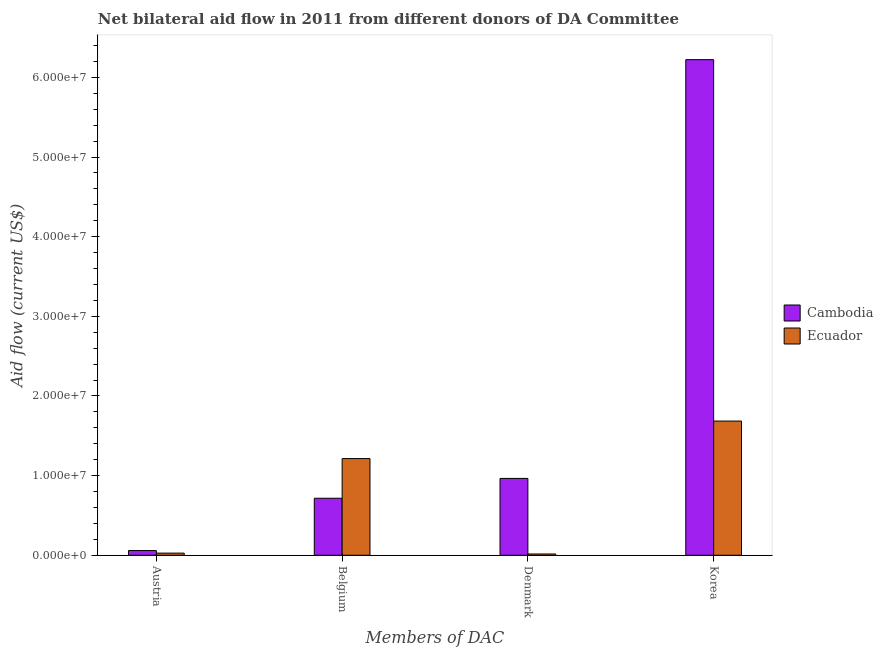How many different coloured bars are there?
Make the answer very short. 2. How many groups of bars are there?
Keep it short and to the point. 4. Are the number of bars on each tick of the X-axis equal?
Ensure brevity in your answer.  Yes. How many bars are there on the 2nd tick from the left?
Your answer should be compact. 2. What is the label of the 4th group of bars from the left?
Ensure brevity in your answer.  Korea. What is the amount of aid given by belgium in Cambodia?
Give a very brief answer. 7.16e+06. Across all countries, what is the maximum amount of aid given by belgium?
Make the answer very short. 1.21e+07. Across all countries, what is the minimum amount of aid given by denmark?
Ensure brevity in your answer.  1.60e+05. In which country was the amount of aid given by denmark maximum?
Provide a short and direct response. Cambodia. In which country was the amount of aid given by belgium minimum?
Your answer should be very brief. Cambodia. What is the total amount of aid given by korea in the graph?
Offer a very short reply. 7.91e+07. What is the difference between the amount of aid given by belgium in Cambodia and that in Ecuador?
Your answer should be compact. -4.98e+06. What is the difference between the amount of aid given by korea in Ecuador and the amount of aid given by belgium in Cambodia?
Provide a succinct answer. 9.69e+06. What is the average amount of aid given by denmark per country?
Provide a succinct answer. 4.90e+06. What is the difference between the amount of aid given by denmark and amount of aid given by korea in Cambodia?
Your answer should be compact. -5.26e+07. In how many countries, is the amount of aid given by austria greater than 38000000 US$?
Your answer should be very brief. 0. What is the ratio of the amount of aid given by austria in Cambodia to that in Ecuador?
Offer a terse response. 2.19. Is the amount of aid given by korea in Ecuador less than that in Cambodia?
Your answer should be very brief. Yes. Is the difference between the amount of aid given by belgium in Ecuador and Cambodia greater than the difference between the amount of aid given by korea in Ecuador and Cambodia?
Provide a succinct answer. Yes. What is the difference between the highest and the second highest amount of aid given by korea?
Offer a terse response. 4.54e+07. What is the difference between the highest and the lowest amount of aid given by denmark?
Offer a terse response. 9.49e+06. Is the sum of the amount of aid given by denmark in Cambodia and Ecuador greater than the maximum amount of aid given by austria across all countries?
Keep it short and to the point. Yes. Is it the case that in every country, the sum of the amount of aid given by denmark and amount of aid given by korea is greater than the sum of amount of aid given by austria and amount of aid given by belgium?
Give a very brief answer. No. What does the 2nd bar from the left in Belgium represents?
Provide a succinct answer. Ecuador. What does the 2nd bar from the right in Korea represents?
Your answer should be very brief. Cambodia. Is it the case that in every country, the sum of the amount of aid given by austria and amount of aid given by belgium is greater than the amount of aid given by denmark?
Your answer should be very brief. No. How many bars are there?
Your response must be concise. 8. How many countries are there in the graph?
Offer a terse response. 2. What is the difference between two consecutive major ticks on the Y-axis?
Give a very brief answer. 1.00e+07. Are the values on the major ticks of Y-axis written in scientific E-notation?
Keep it short and to the point. Yes. Does the graph contain any zero values?
Offer a terse response. No. Does the graph contain grids?
Offer a terse response. No. Where does the legend appear in the graph?
Your answer should be very brief. Center right. How many legend labels are there?
Offer a very short reply. 2. How are the legend labels stacked?
Your response must be concise. Vertical. What is the title of the graph?
Your response must be concise. Net bilateral aid flow in 2011 from different donors of DA Committee. What is the label or title of the X-axis?
Give a very brief answer. Members of DAC. What is the label or title of the Y-axis?
Your answer should be very brief. Aid flow (current US$). What is the Aid flow (current US$) in Cambodia in Austria?
Make the answer very short. 5.90e+05. What is the Aid flow (current US$) in Cambodia in Belgium?
Make the answer very short. 7.16e+06. What is the Aid flow (current US$) in Ecuador in Belgium?
Your response must be concise. 1.21e+07. What is the Aid flow (current US$) of Cambodia in Denmark?
Your response must be concise. 9.65e+06. What is the Aid flow (current US$) in Ecuador in Denmark?
Offer a very short reply. 1.60e+05. What is the Aid flow (current US$) in Cambodia in Korea?
Provide a short and direct response. 6.22e+07. What is the Aid flow (current US$) in Ecuador in Korea?
Make the answer very short. 1.68e+07. Across all Members of DAC, what is the maximum Aid flow (current US$) of Cambodia?
Your response must be concise. 6.22e+07. Across all Members of DAC, what is the maximum Aid flow (current US$) of Ecuador?
Keep it short and to the point. 1.68e+07. Across all Members of DAC, what is the minimum Aid flow (current US$) of Cambodia?
Your response must be concise. 5.90e+05. Across all Members of DAC, what is the minimum Aid flow (current US$) in Ecuador?
Offer a very short reply. 1.60e+05. What is the total Aid flow (current US$) of Cambodia in the graph?
Provide a short and direct response. 7.96e+07. What is the total Aid flow (current US$) of Ecuador in the graph?
Your answer should be compact. 2.94e+07. What is the difference between the Aid flow (current US$) in Cambodia in Austria and that in Belgium?
Your answer should be very brief. -6.57e+06. What is the difference between the Aid flow (current US$) in Ecuador in Austria and that in Belgium?
Your answer should be very brief. -1.19e+07. What is the difference between the Aid flow (current US$) of Cambodia in Austria and that in Denmark?
Offer a terse response. -9.06e+06. What is the difference between the Aid flow (current US$) in Cambodia in Austria and that in Korea?
Make the answer very short. -6.16e+07. What is the difference between the Aid flow (current US$) of Ecuador in Austria and that in Korea?
Provide a short and direct response. -1.66e+07. What is the difference between the Aid flow (current US$) in Cambodia in Belgium and that in Denmark?
Offer a terse response. -2.49e+06. What is the difference between the Aid flow (current US$) of Ecuador in Belgium and that in Denmark?
Provide a succinct answer. 1.20e+07. What is the difference between the Aid flow (current US$) in Cambodia in Belgium and that in Korea?
Keep it short and to the point. -5.51e+07. What is the difference between the Aid flow (current US$) in Ecuador in Belgium and that in Korea?
Your answer should be compact. -4.71e+06. What is the difference between the Aid flow (current US$) in Cambodia in Denmark and that in Korea?
Your response must be concise. -5.26e+07. What is the difference between the Aid flow (current US$) in Ecuador in Denmark and that in Korea?
Your response must be concise. -1.67e+07. What is the difference between the Aid flow (current US$) in Cambodia in Austria and the Aid flow (current US$) in Ecuador in Belgium?
Keep it short and to the point. -1.16e+07. What is the difference between the Aid flow (current US$) in Cambodia in Austria and the Aid flow (current US$) in Ecuador in Denmark?
Give a very brief answer. 4.30e+05. What is the difference between the Aid flow (current US$) in Cambodia in Austria and the Aid flow (current US$) in Ecuador in Korea?
Your response must be concise. -1.63e+07. What is the difference between the Aid flow (current US$) in Cambodia in Belgium and the Aid flow (current US$) in Ecuador in Denmark?
Your response must be concise. 7.00e+06. What is the difference between the Aid flow (current US$) of Cambodia in Belgium and the Aid flow (current US$) of Ecuador in Korea?
Ensure brevity in your answer.  -9.69e+06. What is the difference between the Aid flow (current US$) of Cambodia in Denmark and the Aid flow (current US$) of Ecuador in Korea?
Your answer should be very brief. -7.20e+06. What is the average Aid flow (current US$) of Cambodia per Members of DAC?
Your answer should be very brief. 1.99e+07. What is the average Aid flow (current US$) of Ecuador per Members of DAC?
Make the answer very short. 7.36e+06. What is the difference between the Aid flow (current US$) in Cambodia and Aid flow (current US$) in Ecuador in Austria?
Provide a short and direct response. 3.20e+05. What is the difference between the Aid flow (current US$) of Cambodia and Aid flow (current US$) of Ecuador in Belgium?
Your answer should be compact. -4.98e+06. What is the difference between the Aid flow (current US$) of Cambodia and Aid flow (current US$) of Ecuador in Denmark?
Your response must be concise. 9.49e+06. What is the difference between the Aid flow (current US$) of Cambodia and Aid flow (current US$) of Ecuador in Korea?
Keep it short and to the point. 4.54e+07. What is the ratio of the Aid flow (current US$) of Cambodia in Austria to that in Belgium?
Offer a terse response. 0.08. What is the ratio of the Aid flow (current US$) in Ecuador in Austria to that in Belgium?
Keep it short and to the point. 0.02. What is the ratio of the Aid flow (current US$) of Cambodia in Austria to that in Denmark?
Provide a short and direct response. 0.06. What is the ratio of the Aid flow (current US$) of Ecuador in Austria to that in Denmark?
Your answer should be very brief. 1.69. What is the ratio of the Aid flow (current US$) of Cambodia in Austria to that in Korea?
Your answer should be compact. 0.01. What is the ratio of the Aid flow (current US$) of Ecuador in Austria to that in Korea?
Offer a terse response. 0.02. What is the ratio of the Aid flow (current US$) in Cambodia in Belgium to that in Denmark?
Provide a short and direct response. 0.74. What is the ratio of the Aid flow (current US$) of Ecuador in Belgium to that in Denmark?
Keep it short and to the point. 75.88. What is the ratio of the Aid flow (current US$) in Cambodia in Belgium to that in Korea?
Make the answer very short. 0.12. What is the ratio of the Aid flow (current US$) of Ecuador in Belgium to that in Korea?
Make the answer very short. 0.72. What is the ratio of the Aid flow (current US$) in Cambodia in Denmark to that in Korea?
Your answer should be very brief. 0.16. What is the ratio of the Aid flow (current US$) of Ecuador in Denmark to that in Korea?
Your answer should be very brief. 0.01. What is the difference between the highest and the second highest Aid flow (current US$) of Cambodia?
Offer a very short reply. 5.26e+07. What is the difference between the highest and the second highest Aid flow (current US$) in Ecuador?
Ensure brevity in your answer.  4.71e+06. What is the difference between the highest and the lowest Aid flow (current US$) in Cambodia?
Give a very brief answer. 6.16e+07. What is the difference between the highest and the lowest Aid flow (current US$) of Ecuador?
Give a very brief answer. 1.67e+07. 